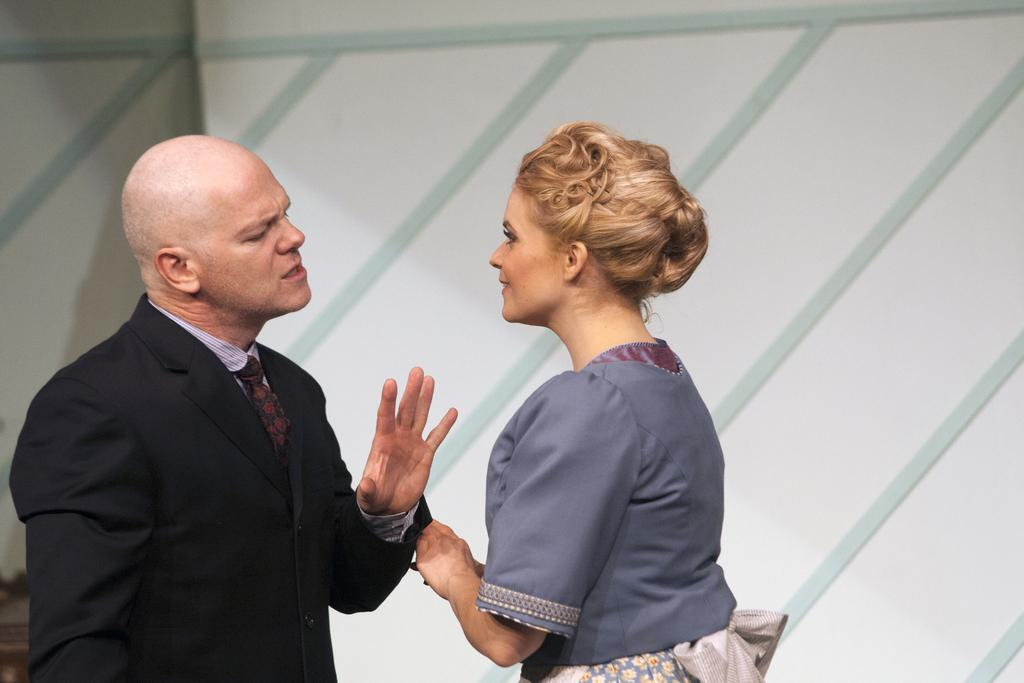How many people are present in the image? There are two people, a man and a woman, present in the image. What can be seen in the background of the image? There is a wall in the background of the image. What is the woman thinking about in the image? There is no information about the woman's thoughts in the image, so it cannot be determined from the image alone. 